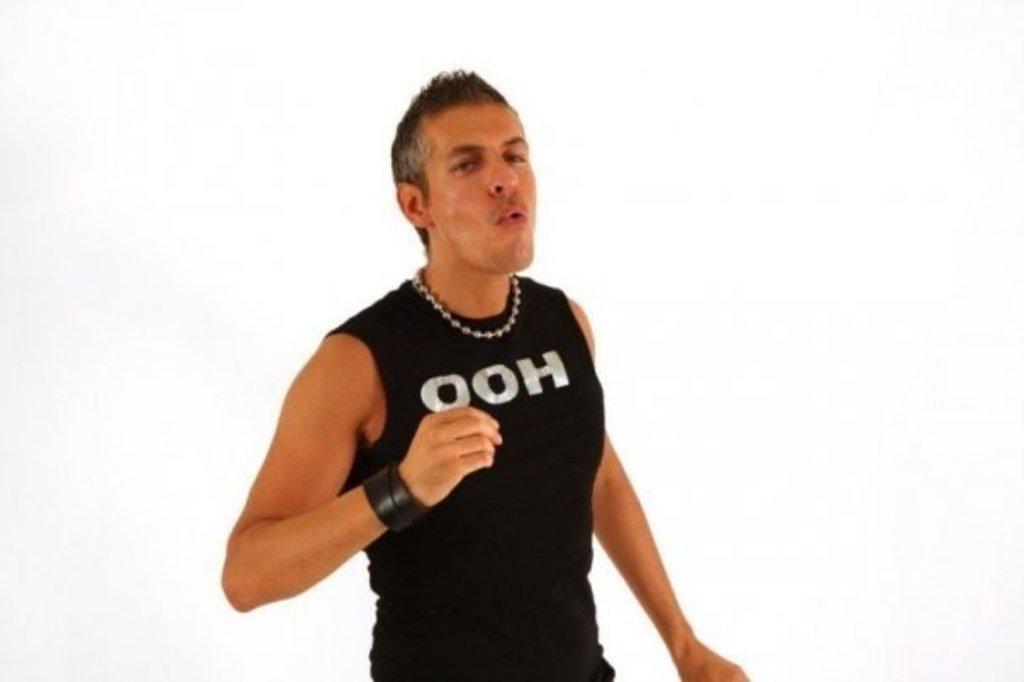What does the person's shirt say?
Provide a succinct answer. Ooh. 